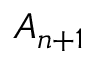Convert formula to latex. <formula><loc_0><loc_0><loc_500><loc_500>A _ { n + 1 }</formula> 